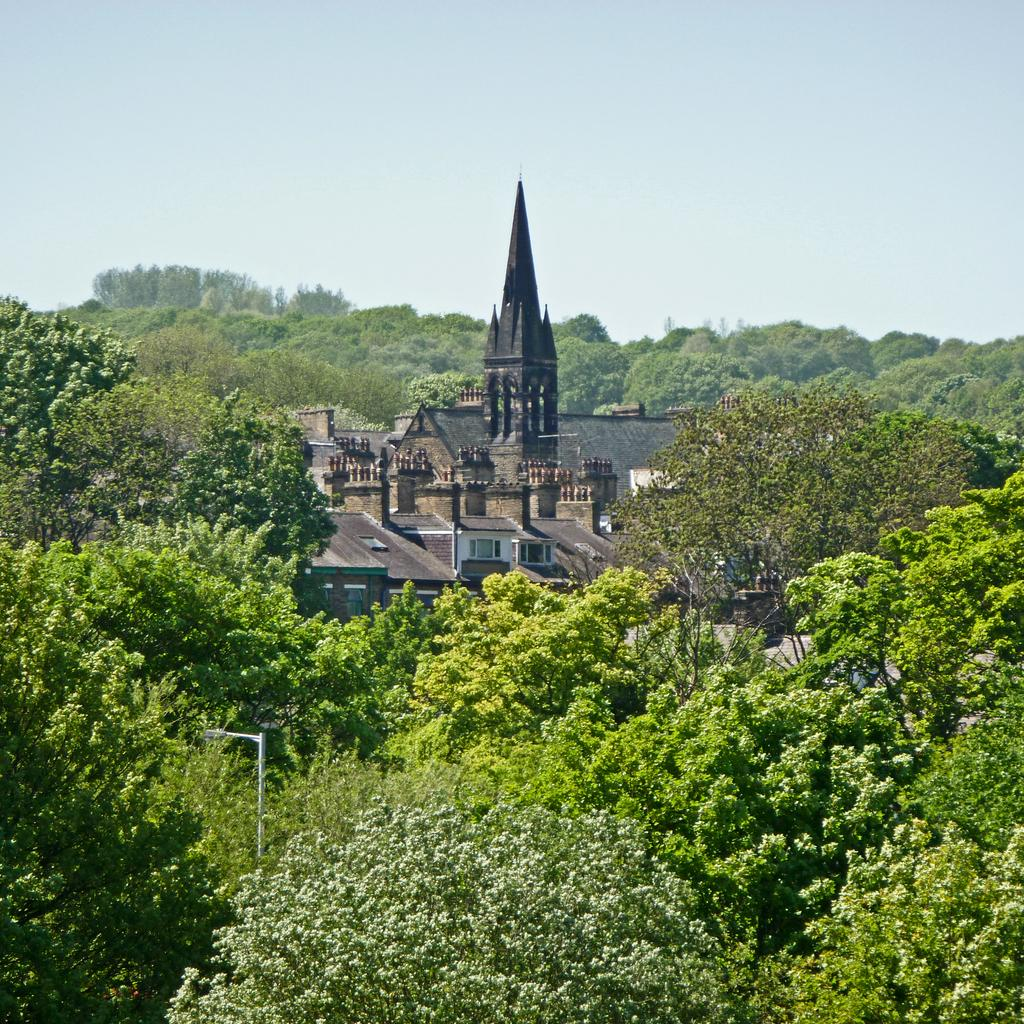What type of natural elements can be seen in the image? There are trees in the image. What type of man-made structures are present in the image? There are buildings in the image. What part of the natural environment is visible in the image? The sky is visible in the image. How much payment is required to enter the buildings in the image? There is no information about payment or entering the buildings in the image. 